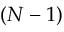<formula> <loc_0><loc_0><loc_500><loc_500>( N - 1 )</formula> 